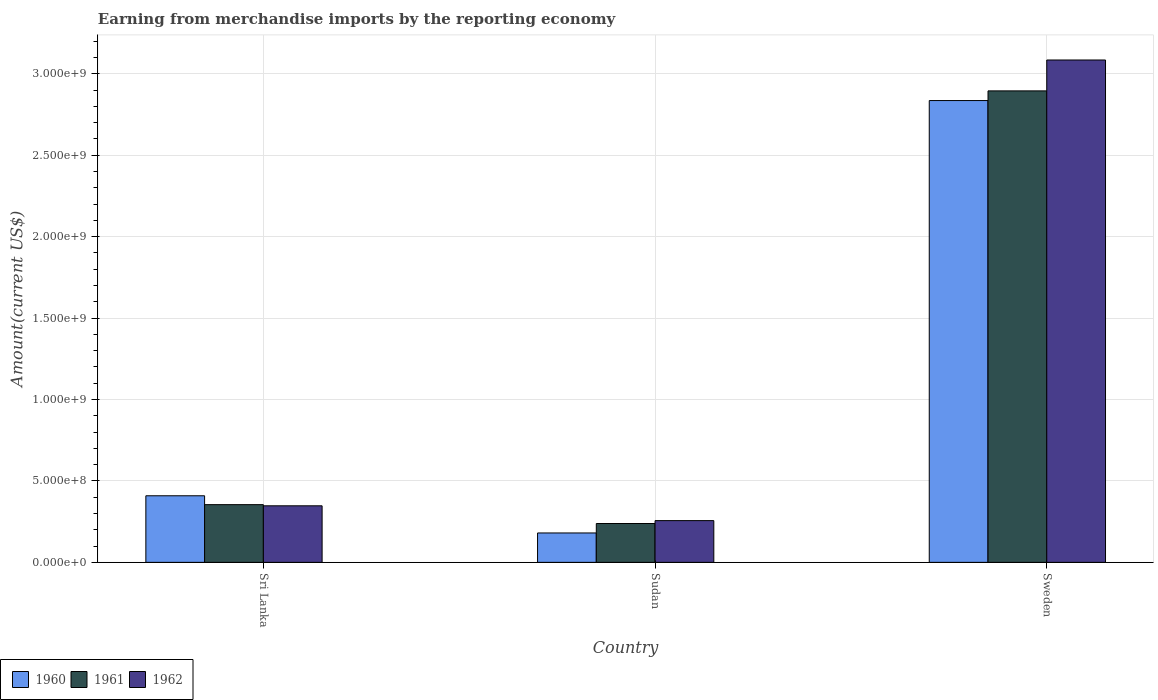How many groups of bars are there?
Keep it short and to the point. 3. Are the number of bars per tick equal to the number of legend labels?
Your answer should be very brief. Yes. What is the label of the 2nd group of bars from the left?
Provide a succinct answer. Sudan. What is the amount earned from merchandise imports in 1962 in Sudan?
Your answer should be compact. 2.56e+08. Across all countries, what is the maximum amount earned from merchandise imports in 1962?
Give a very brief answer. 3.08e+09. Across all countries, what is the minimum amount earned from merchandise imports in 1960?
Make the answer very short. 1.80e+08. In which country was the amount earned from merchandise imports in 1960 maximum?
Offer a terse response. Sweden. In which country was the amount earned from merchandise imports in 1961 minimum?
Ensure brevity in your answer.  Sudan. What is the total amount earned from merchandise imports in 1962 in the graph?
Your response must be concise. 3.69e+09. What is the difference between the amount earned from merchandise imports in 1960 in Sri Lanka and that in Sudan?
Give a very brief answer. 2.28e+08. What is the difference between the amount earned from merchandise imports in 1960 in Sri Lanka and the amount earned from merchandise imports in 1961 in Sudan?
Offer a terse response. 1.70e+08. What is the average amount earned from merchandise imports in 1961 per country?
Give a very brief answer. 1.16e+09. What is the difference between the amount earned from merchandise imports of/in 1961 and amount earned from merchandise imports of/in 1960 in Sudan?
Your answer should be compact. 5.80e+07. In how many countries, is the amount earned from merchandise imports in 1962 greater than 600000000 US$?
Give a very brief answer. 1. What is the ratio of the amount earned from merchandise imports in 1961 in Sudan to that in Sweden?
Your response must be concise. 0.08. What is the difference between the highest and the second highest amount earned from merchandise imports in 1960?
Make the answer very short. 2.43e+09. What is the difference between the highest and the lowest amount earned from merchandise imports in 1960?
Your answer should be compact. 2.66e+09. In how many countries, is the amount earned from merchandise imports in 1962 greater than the average amount earned from merchandise imports in 1962 taken over all countries?
Your answer should be compact. 1. Is the sum of the amount earned from merchandise imports in 1962 in Sri Lanka and Sweden greater than the maximum amount earned from merchandise imports in 1960 across all countries?
Provide a short and direct response. Yes. What does the 3rd bar from the left in Sri Lanka represents?
Make the answer very short. 1962. How many bars are there?
Offer a terse response. 9. Are all the bars in the graph horizontal?
Offer a terse response. No. How many countries are there in the graph?
Offer a very short reply. 3. Are the values on the major ticks of Y-axis written in scientific E-notation?
Your response must be concise. Yes. Does the graph contain any zero values?
Provide a succinct answer. No. How are the legend labels stacked?
Offer a terse response. Horizontal. What is the title of the graph?
Ensure brevity in your answer.  Earning from merchandise imports by the reporting economy. What is the label or title of the X-axis?
Ensure brevity in your answer.  Country. What is the label or title of the Y-axis?
Your response must be concise. Amount(current US$). What is the Amount(current US$) in 1960 in Sri Lanka?
Provide a succinct answer. 4.09e+08. What is the Amount(current US$) in 1961 in Sri Lanka?
Give a very brief answer. 3.54e+08. What is the Amount(current US$) of 1962 in Sri Lanka?
Offer a very short reply. 3.47e+08. What is the Amount(current US$) in 1960 in Sudan?
Your response must be concise. 1.80e+08. What is the Amount(current US$) in 1961 in Sudan?
Offer a terse response. 2.38e+08. What is the Amount(current US$) of 1962 in Sudan?
Keep it short and to the point. 2.56e+08. What is the Amount(current US$) in 1960 in Sweden?
Ensure brevity in your answer.  2.84e+09. What is the Amount(current US$) in 1961 in Sweden?
Your answer should be compact. 2.89e+09. What is the Amount(current US$) in 1962 in Sweden?
Make the answer very short. 3.08e+09. Across all countries, what is the maximum Amount(current US$) of 1960?
Your answer should be very brief. 2.84e+09. Across all countries, what is the maximum Amount(current US$) of 1961?
Offer a very short reply. 2.89e+09. Across all countries, what is the maximum Amount(current US$) of 1962?
Ensure brevity in your answer.  3.08e+09. Across all countries, what is the minimum Amount(current US$) in 1960?
Offer a very short reply. 1.80e+08. Across all countries, what is the minimum Amount(current US$) in 1961?
Offer a terse response. 2.38e+08. Across all countries, what is the minimum Amount(current US$) in 1962?
Provide a succinct answer. 2.56e+08. What is the total Amount(current US$) in 1960 in the graph?
Your response must be concise. 3.42e+09. What is the total Amount(current US$) of 1961 in the graph?
Your answer should be compact. 3.49e+09. What is the total Amount(current US$) in 1962 in the graph?
Ensure brevity in your answer.  3.69e+09. What is the difference between the Amount(current US$) of 1960 in Sri Lanka and that in Sudan?
Your answer should be very brief. 2.28e+08. What is the difference between the Amount(current US$) of 1961 in Sri Lanka and that in Sudan?
Your response must be concise. 1.16e+08. What is the difference between the Amount(current US$) in 1962 in Sri Lanka and that in Sudan?
Provide a succinct answer. 9.09e+07. What is the difference between the Amount(current US$) in 1960 in Sri Lanka and that in Sweden?
Your answer should be very brief. -2.43e+09. What is the difference between the Amount(current US$) of 1961 in Sri Lanka and that in Sweden?
Keep it short and to the point. -2.54e+09. What is the difference between the Amount(current US$) in 1962 in Sri Lanka and that in Sweden?
Ensure brevity in your answer.  -2.74e+09. What is the difference between the Amount(current US$) of 1960 in Sudan and that in Sweden?
Offer a very short reply. -2.66e+09. What is the difference between the Amount(current US$) in 1961 in Sudan and that in Sweden?
Provide a short and direct response. -2.66e+09. What is the difference between the Amount(current US$) of 1962 in Sudan and that in Sweden?
Give a very brief answer. -2.83e+09. What is the difference between the Amount(current US$) in 1960 in Sri Lanka and the Amount(current US$) in 1961 in Sudan?
Your response must be concise. 1.70e+08. What is the difference between the Amount(current US$) of 1960 in Sri Lanka and the Amount(current US$) of 1962 in Sudan?
Give a very brief answer. 1.52e+08. What is the difference between the Amount(current US$) in 1961 in Sri Lanka and the Amount(current US$) in 1962 in Sudan?
Provide a short and direct response. 9.80e+07. What is the difference between the Amount(current US$) in 1960 in Sri Lanka and the Amount(current US$) in 1961 in Sweden?
Offer a very short reply. -2.49e+09. What is the difference between the Amount(current US$) in 1960 in Sri Lanka and the Amount(current US$) in 1962 in Sweden?
Provide a short and direct response. -2.68e+09. What is the difference between the Amount(current US$) of 1961 in Sri Lanka and the Amount(current US$) of 1962 in Sweden?
Make the answer very short. -2.73e+09. What is the difference between the Amount(current US$) in 1960 in Sudan and the Amount(current US$) in 1961 in Sweden?
Offer a very short reply. -2.71e+09. What is the difference between the Amount(current US$) of 1960 in Sudan and the Amount(current US$) of 1962 in Sweden?
Your response must be concise. -2.90e+09. What is the difference between the Amount(current US$) of 1961 in Sudan and the Amount(current US$) of 1962 in Sweden?
Your answer should be very brief. -2.85e+09. What is the average Amount(current US$) of 1960 per country?
Offer a very short reply. 1.14e+09. What is the average Amount(current US$) of 1961 per country?
Give a very brief answer. 1.16e+09. What is the average Amount(current US$) of 1962 per country?
Your answer should be very brief. 1.23e+09. What is the difference between the Amount(current US$) in 1960 and Amount(current US$) in 1961 in Sri Lanka?
Make the answer very short. 5.45e+07. What is the difference between the Amount(current US$) in 1960 and Amount(current US$) in 1962 in Sri Lanka?
Offer a terse response. 6.16e+07. What is the difference between the Amount(current US$) in 1961 and Amount(current US$) in 1962 in Sri Lanka?
Offer a terse response. 7.10e+06. What is the difference between the Amount(current US$) of 1960 and Amount(current US$) of 1961 in Sudan?
Make the answer very short. -5.80e+07. What is the difference between the Amount(current US$) in 1960 and Amount(current US$) in 1962 in Sudan?
Your answer should be compact. -7.58e+07. What is the difference between the Amount(current US$) of 1961 and Amount(current US$) of 1962 in Sudan?
Keep it short and to the point. -1.78e+07. What is the difference between the Amount(current US$) of 1960 and Amount(current US$) of 1961 in Sweden?
Offer a terse response. -5.93e+07. What is the difference between the Amount(current US$) in 1960 and Amount(current US$) in 1962 in Sweden?
Give a very brief answer. -2.49e+08. What is the difference between the Amount(current US$) in 1961 and Amount(current US$) in 1962 in Sweden?
Your answer should be very brief. -1.90e+08. What is the ratio of the Amount(current US$) of 1960 in Sri Lanka to that in Sudan?
Keep it short and to the point. 2.26. What is the ratio of the Amount(current US$) in 1961 in Sri Lanka to that in Sudan?
Ensure brevity in your answer.  1.49. What is the ratio of the Amount(current US$) of 1962 in Sri Lanka to that in Sudan?
Offer a terse response. 1.35. What is the ratio of the Amount(current US$) of 1960 in Sri Lanka to that in Sweden?
Your answer should be compact. 0.14. What is the ratio of the Amount(current US$) in 1961 in Sri Lanka to that in Sweden?
Your answer should be compact. 0.12. What is the ratio of the Amount(current US$) in 1962 in Sri Lanka to that in Sweden?
Offer a very short reply. 0.11. What is the ratio of the Amount(current US$) of 1960 in Sudan to that in Sweden?
Ensure brevity in your answer.  0.06. What is the ratio of the Amount(current US$) in 1961 in Sudan to that in Sweden?
Make the answer very short. 0.08. What is the ratio of the Amount(current US$) in 1962 in Sudan to that in Sweden?
Ensure brevity in your answer.  0.08. What is the difference between the highest and the second highest Amount(current US$) of 1960?
Provide a succinct answer. 2.43e+09. What is the difference between the highest and the second highest Amount(current US$) of 1961?
Make the answer very short. 2.54e+09. What is the difference between the highest and the second highest Amount(current US$) of 1962?
Offer a terse response. 2.74e+09. What is the difference between the highest and the lowest Amount(current US$) of 1960?
Offer a very short reply. 2.66e+09. What is the difference between the highest and the lowest Amount(current US$) in 1961?
Provide a short and direct response. 2.66e+09. What is the difference between the highest and the lowest Amount(current US$) of 1962?
Give a very brief answer. 2.83e+09. 